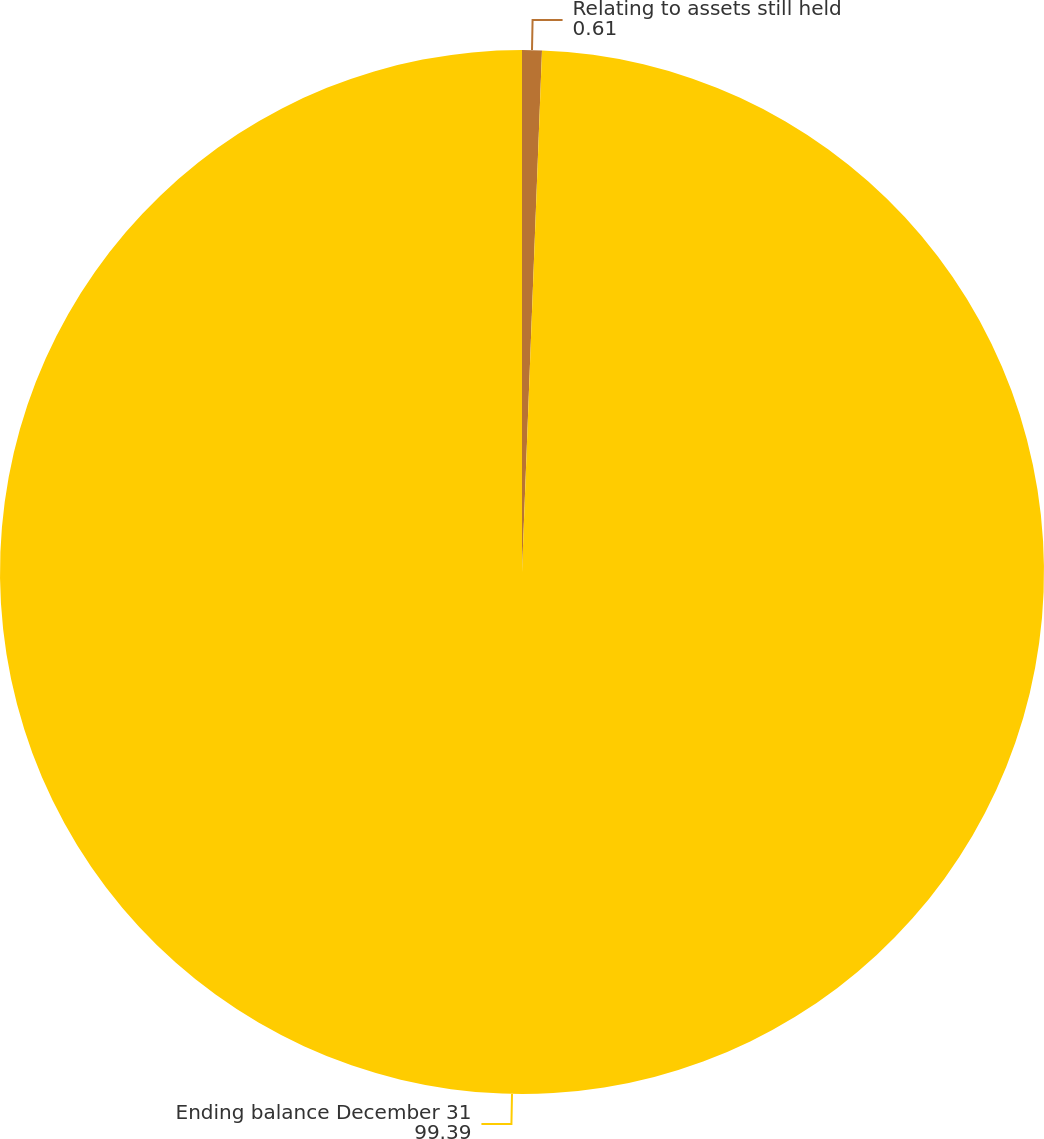Convert chart to OTSL. <chart><loc_0><loc_0><loc_500><loc_500><pie_chart><fcel>Relating to assets still held<fcel>Ending balance December 31<nl><fcel>0.61%<fcel>99.39%<nl></chart> 